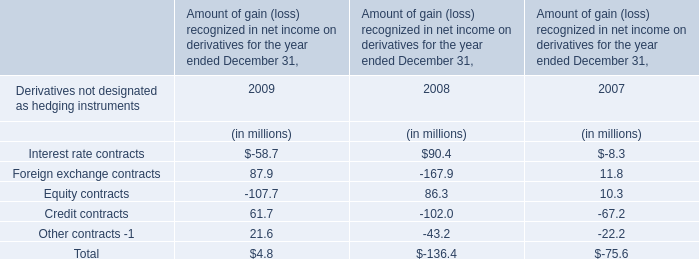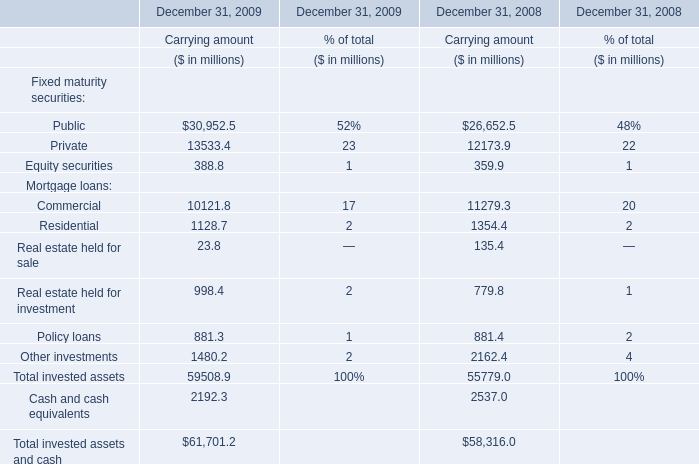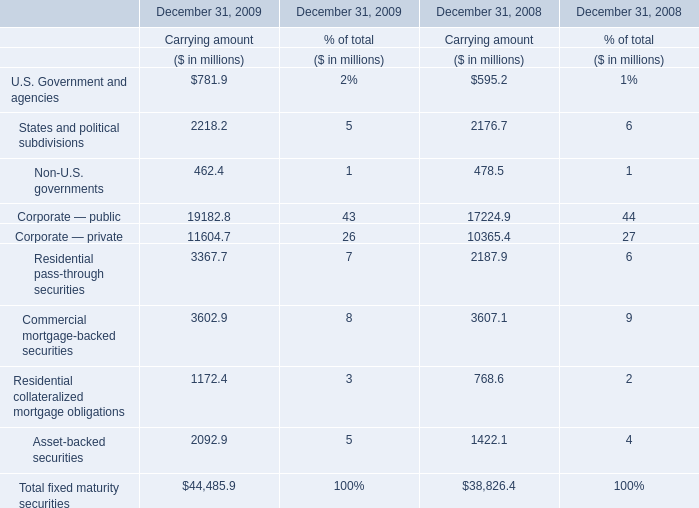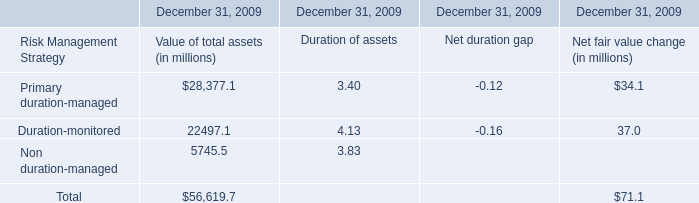What is the total value of U.S. Government and agencies, States and political subdivisions, Non-U.S. governments and Corporate — public for Carrying amount in 2009? (in million) 
Computations: (((781.9 + 2218.2) + 462.4) + 19182.8)
Answer: 22645.3. 